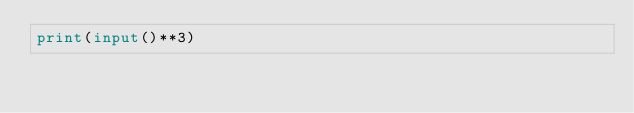<code> <loc_0><loc_0><loc_500><loc_500><_Python_>print(input()**3)</code> 